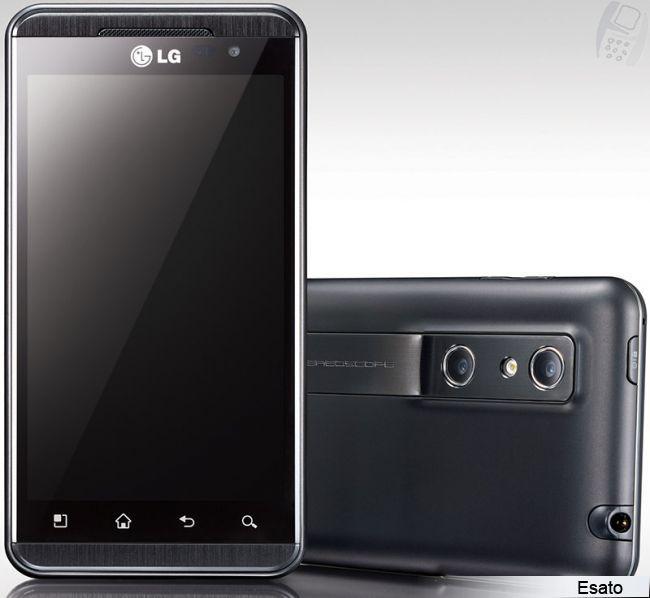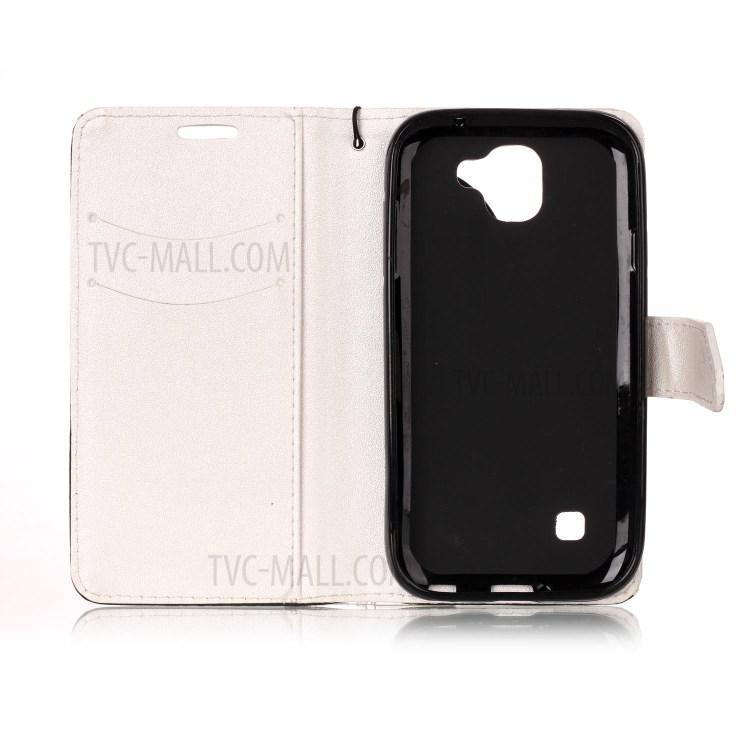The first image is the image on the left, the second image is the image on the right. Assess this claim about the two images: "The left and right image contains the same number of cell phones.". Correct or not? Answer yes or no. No. The first image is the image on the left, the second image is the image on the right. Assess this claim about the two images: "The right image shows a wallet phone case that is open with no cell phone in it.". Correct or not? Answer yes or no. Yes. 